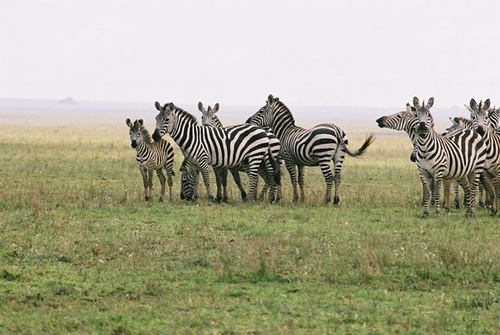Describe the objects in this image and their specific colors. I can see zebra in white, black, gray, lightgray, and darkgray tones, zebra in white, black, gray, and darkgray tones, zebra in white, black, gray, darkgray, and lightgray tones, zebra in white, gray, black, and darkgreen tones, and zebra in white, black, gray, darkgreen, and darkgray tones in this image. 